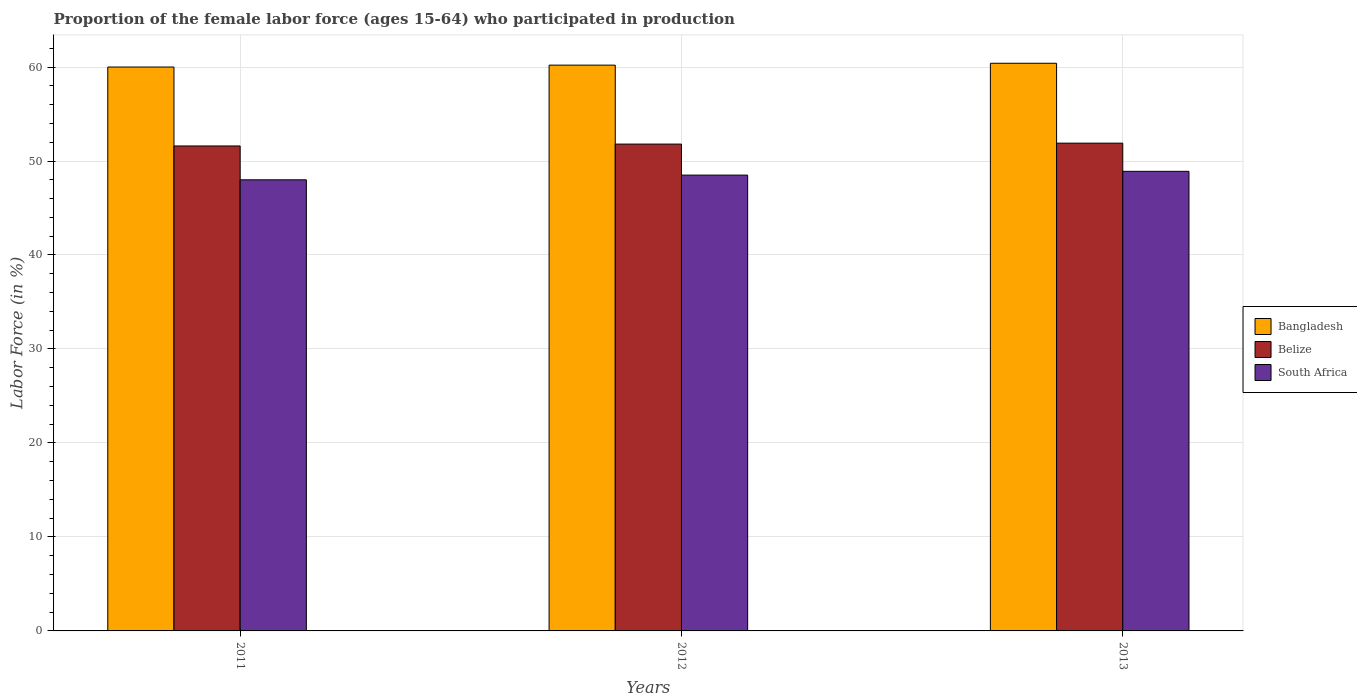How many different coloured bars are there?
Your answer should be compact. 3. Are the number of bars per tick equal to the number of legend labels?
Ensure brevity in your answer.  Yes. Are the number of bars on each tick of the X-axis equal?
Keep it short and to the point. Yes. In how many cases, is the number of bars for a given year not equal to the number of legend labels?
Give a very brief answer. 0. What is the proportion of the female labor force who participated in production in South Africa in 2012?
Offer a very short reply. 48.5. Across all years, what is the maximum proportion of the female labor force who participated in production in Belize?
Your answer should be compact. 51.9. In which year was the proportion of the female labor force who participated in production in Belize maximum?
Offer a very short reply. 2013. What is the total proportion of the female labor force who participated in production in Belize in the graph?
Provide a succinct answer. 155.3. What is the difference between the proportion of the female labor force who participated in production in Bangladesh in 2011 and that in 2012?
Your answer should be compact. -0.2. What is the difference between the proportion of the female labor force who participated in production in Bangladesh in 2012 and the proportion of the female labor force who participated in production in South Africa in 2013?
Provide a short and direct response. 11.3. What is the average proportion of the female labor force who participated in production in Belize per year?
Keep it short and to the point. 51.77. In the year 2013, what is the difference between the proportion of the female labor force who participated in production in Belize and proportion of the female labor force who participated in production in South Africa?
Your answer should be compact. 3. What is the ratio of the proportion of the female labor force who participated in production in Belize in 2011 to that in 2013?
Your answer should be compact. 0.99. Is the proportion of the female labor force who participated in production in Bangladesh in 2011 less than that in 2012?
Offer a terse response. Yes. Is the difference between the proportion of the female labor force who participated in production in Belize in 2012 and 2013 greater than the difference between the proportion of the female labor force who participated in production in South Africa in 2012 and 2013?
Your answer should be compact. Yes. What is the difference between the highest and the second highest proportion of the female labor force who participated in production in Belize?
Your answer should be compact. 0.1. What is the difference between the highest and the lowest proportion of the female labor force who participated in production in Belize?
Offer a terse response. 0.3. In how many years, is the proportion of the female labor force who participated in production in South Africa greater than the average proportion of the female labor force who participated in production in South Africa taken over all years?
Provide a short and direct response. 2. Is the sum of the proportion of the female labor force who participated in production in Belize in 2011 and 2012 greater than the maximum proportion of the female labor force who participated in production in Bangladesh across all years?
Give a very brief answer. Yes. What does the 3rd bar from the left in 2012 represents?
Your response must be concise. South Africa. What does the 2nd bar from the right in 2013 represents?
Offer a terse response. Belize. Is it the case that in every year, the sum of the proportion of the female labor force who participated in production in South Africa and proportion of the female labor force who participated in production in Belize is greater than the proportion of the female labor force who participated in production in Bangladesh?
Your answer should be compact. Yes. Are the values on the major ticks of Y-axis written in scientific E-notation?
Provide a succinct answer. No. Does the graph contain grids?
Ensure brevity in your answer.  Yes. Where does the legend appear in the graph?
Give a very brief answer. Center right. How are the legend labels stacked?
Provide a succinct answer. Vertical. What is the title of the graph?
Offer a terse response. Proportion of the female labor force (ages 15-64) who participated in production. What is the label or title of the Y-axis?
Keep it short and to the point. Labor Force (in %). What is the Labor Force (in %) in Bangladesh in 2011?
Your answer should be very brief. 60. What is the Labor Force (in %) in Belize in 2011?
Provide a short and direct response. 51.6. What is the Labor Force (in %) of South Africa in 2011?
Your answer should be compact. 48. What is the Labor Force (in %) in Bangladesh in 2012?
Give a very brief answer. 60.2. What is the Labor Force (in %) of Belize in 2012?
Your response must be concise. 51.8. What is the Labor Force (in %) of South Africa in 2012?
Provide a short and direct response. 48.5. What is the Labor Force (in %) of Bangladesh in 2013?
Offer a very short reply. 60.4. What is the Labor Force (in %) of Belize in 2013?
Provide a short and direct response. 51.9. What is the Labor Force (in %) of South Africa in 2013?
Your answer should be very brief. 48.9. Across all years, what is the maximum Labor Force (in %) of Bangladesh?
Your answer should be very brief. 60.4. Across all years, what is the maximum Labor Force (in %) in Belize?
Offer a terse response. 51.9. Across all years, what is the maximum Labor Force (in %) in South Africa?
Ensure brevity in your answer.  48.9. Across all years, what is the minimum Labor Force (in %) in Bangladesh?
Your answer should be very brief. 60. Across all years, what is the minimum Labor Force (in %) in Belize?
Your answer should be very brief. 51.6. What is the total Labor Force (in %) in Bangladesh in the graph?
Keep it short and to the point. 180.6. What is the total Labor Force (in %) of Belize in the graph?
Make the answer very short. 155.3. What is the total Labor Force (in %) of South Africa in the graph?
Offer a very short reply. 145.4. What is the difference between the Labor Force (in %) of Bangladesh in 2011 and that in 2013?
Your answer should be very brief. -0.4. What is the difference between the Labor Force (in %) of Bangladesh in 2012 and that in 2013?
Offer a terse response. -0.2. What is the difference between the Labor Force (in %) of South Africa in 2012 and that in 2013?
Your response must be concise. -0.4. What is the difference between the Labor Force (in %) in Bangladesh in 2011 and the Labor Force (in %) in Belize in 2012?
Offer a very short reply. 8.2. What is the difference between the Labor Force (in %) in Bangladesh in 2011 and the Labor Force (in %) in South Africa in 2012?
Provide a succinct answer. 11.5. What is the difference between the Labor Force (in %) of Bangladesh in 2011 and the Labor Force (in %) of Belize in 2013?
Ensure brevity in your answer.  8.1. What is the difference between the Labor Force (in %) of Bangladesh in 2011 and the Labor Force (in %) of South Africa in 2013?
Offer a very short reply. 11.1. What is the difference between the Labor Force (in %) in Bangladesh in 2012 and the Labor Force (in %) in Belize in 2013?
Make the answer very short. 8.3. What is the difference between the Labor Force (in %) in Bangladesh in 2012 and the Labor Force (in %) in South Africa in 2013?
Give a very brief answer. 11.3. What is the average Labor Force (in %) of Bangladesh per year?
Ensure brevity in your answer.  60.2. What is the average Labor Force (in %) in Belize per year?
Your answer should be compact. 51.77. What is the average Labor Force (in %) in South Africa per year?
Provide a succinct answer. 48.47. In the year 2011, what is the difference between the Labor Force (in %) in Bangladesh and Labor Force (in %) in South Africa?
Give a very brief answer. 12. In the year 2011, what is the difference between the Labor Force (in %) in Belize and Labor Force (in %) in South Africa?
Your response must be concise. 3.6. In the year 2012, what is the difference between the Labor Force (in %) of Bangladesh and Labor Force (in %) of Belize?
Keep it short and to the point. 8.4. In the year 2013, what is the difference between the Labor Force (in %) of Bangladesh and Labor Force (in %) of Belize?
Offer a very short reply. 8.5. In the year 2013, what is the difference between the Labor Force (in %) in Belize and Labor Force (in %) in South Africa?
Your response must be concise. 3. What is the ratio of the Labor Force (in %) of Bangladesh in 2011 to that in 2012?
Ensure brevity in your answer.  1. What is the ratio of the Labor Force (in %) of South Africa in 2011 to that in 2012?
Provide a short and direct response. 0.99. What is the ratio of the Labor Force (in %) of Bangladesh in 2011 to that in 2013?
Give a very brief answer. 0.99. What is the ratio of the Labor Force (in %) of South Africa in 2011 to that in 2013?
Keep it short and to the point. 0.98. What is the ratio of the Labor Force (in %) of South Africa in 2012 to that in 2013?
Your response must be concise. 0.99. What is the difference between the highest and the second highest Labor Force (in %) in Belize?
Your answer should be compact. 0.1. What is the difference between the highest and the second highest Labor Force (in %) of South Africa?
Ensure brevity in your answer.  0.4. What is the difference between the highest and the lowest Labor Force (in %) in Bangladesh?
Your response must be concise. 0.4. 